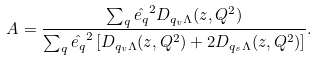Convert formula to latex. <formula><loc_0><loc_0><loc_500><loc_500>A = \frac { \sum _ { q } \hat { e _ { q } } ^ { 2 } D _ { q _ { v } \Lambda } ( z , Q ^ { 2 } ) } { \sum _ { q } \hat { e _ { q } } ^ { 2 } \left [ D _ { q _ { v } \Lambda } ( z , Q ^ { 2 } ) + 2 D _ { q _ { s } \Lambda } ( z , Q ^ { 2 } ) \right ] } .</formula> 